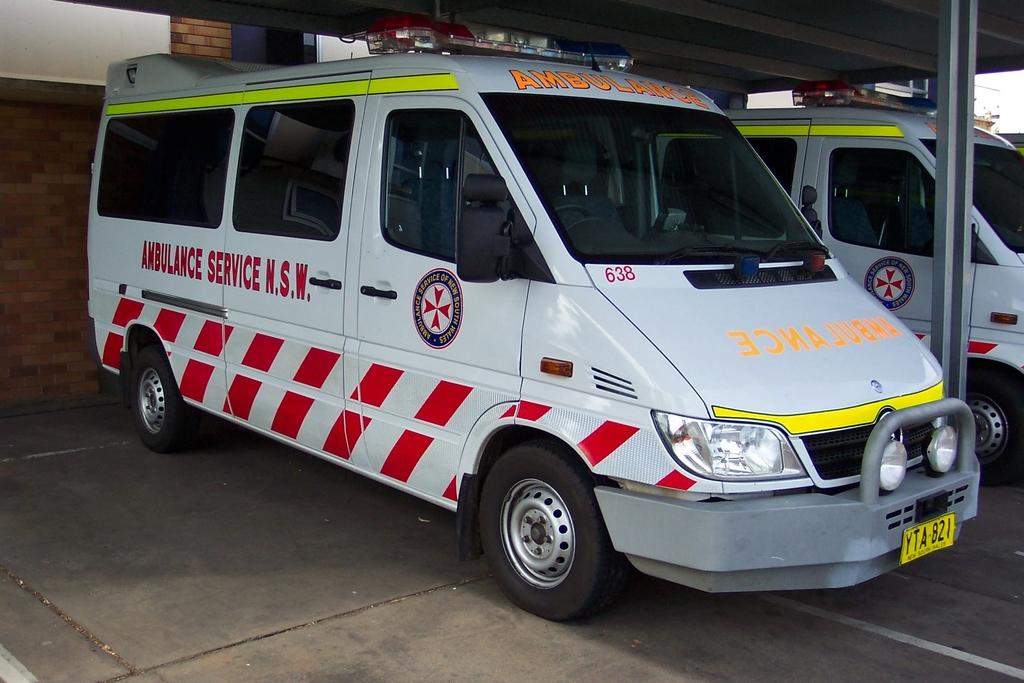What emergency response vehicle is that?
Provide a short and direct response. Ambulance. What does the front license plate say?
Your response must be concise. Yta 821. 